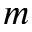<formula> <loc_0><loc_0><loc_500><loc_500>m</formula> 